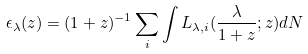<formula> <loc_0><loc_0><loc_500><loc_500>\epsilon _ { \lambda } ( z ) = ( 1 + z ) ^ { - 1 } \sum _ { i } \int L _ { \lambda , i } ( \frac { \lambda } { 1 + z } ; z ) d N</formula> 